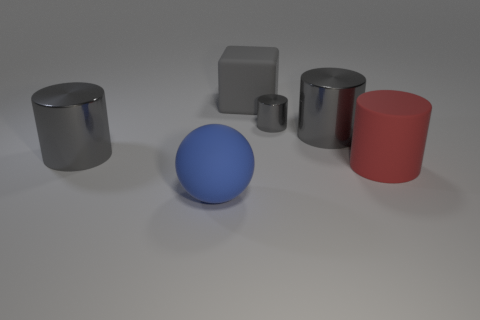Subtract all gray metal cylinders. How many cylinders are left? 1 Subtract all gray blocks. How many gray cylinders are left? 3 Subtract all red cylinders. How many cylinders are left? 3 Subtract all cubes. How many objects are left? 5 Add 3 large red objects. How many objects exist? 9 Add 2 big gray shiny cylinders. How many big gray shiny cylinders are left? 4 Add 4 tiny green matte cubes. How many tiny green matte cubes exist? 4 Subtract 1 blue balls. How many objects are left? 5 Subtract all blue cubes. Subtract all cyan balls. How many cubes are left? 1 Subtract all large objects. Subtract all blue things. How many objects are left? 0 